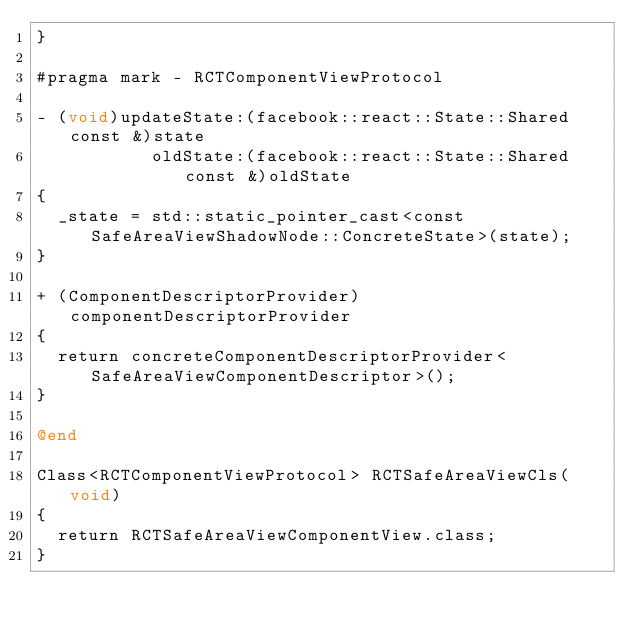Convert code to text. <code><loc_0><loc_0><loc_500><loc_500><_ObjectiveC_>}

#pragma mark - RCTComponentViewProtocol

- (void)updateState:(facebook::react::State::Shared const &)state
           oldState:(facebook::react::State::Shared const &)oldState
{
  _state = std::static_pointer_cast<const SafeAreaViewShadowNode::ConcreteState>(state);
}

+ (ComponentDescriptorProvider)componentDescriptorProvider
{
  return concreteComponentDescriptorProvider<SafeAreaViewComponentDescriptor>();
}

@end

Class<RCTComponentViewProtocol> RCTSafeAreaViewCls(void)
{
  return RCTSafeAreaViewComponentView.class;
}
</code> 